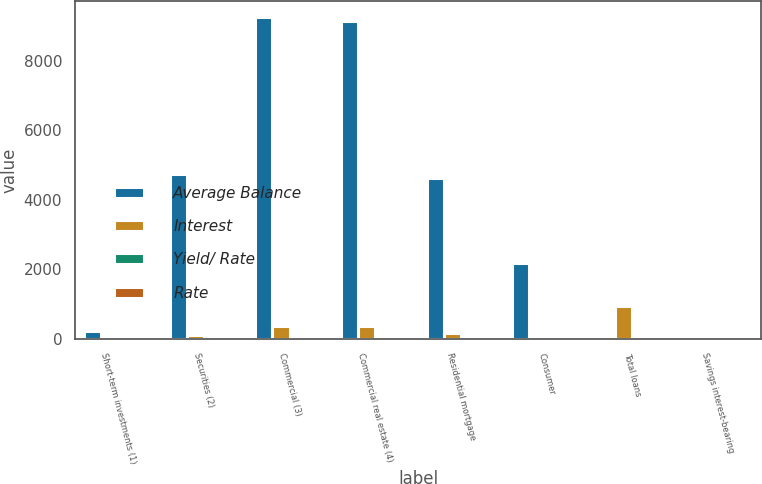<chart> <loc_0><loc_0><loc_500><loc_500><stacked_bar_chart><ecel><fcel>Short-term investments (1)<fcel>Securities (2)<fcel>Commercial (3)<fcel>Commercial real estate (4)<fcel>Residential mortgage<fcel>Consumer<fcel>Total loans<fcel>Savings interest-bearing<nl><fcel>Average Balance<fcel>214.9<fcel>4746.9<fcel>9266.2<fcel>9145<fcel>4635.1<fcel>2172.7<fcel>4.76<fcel>4.76<nl><fcel>Interest<fcel>0.4<fcel>106.3<fcel>360.7<fcel>354.2<fcel>154.3<fcel>73.9<fcel>943.1<fcel>36.7<nl><fcel>Yield/ Rate<fcel>0.2<fcel>2.24<fcel>3.89<fcel>3.87<fcel>3.33<fcel>3.4<fcel>3.74<fcel>0.26<nl><fcel>Rate<fcel>0.24<fcel>2.47<fcel>4.87<fcel>5.2<fcel>3.77<fcel>3.68<fcel>4.65<fcel>0.33<nl></chart> 